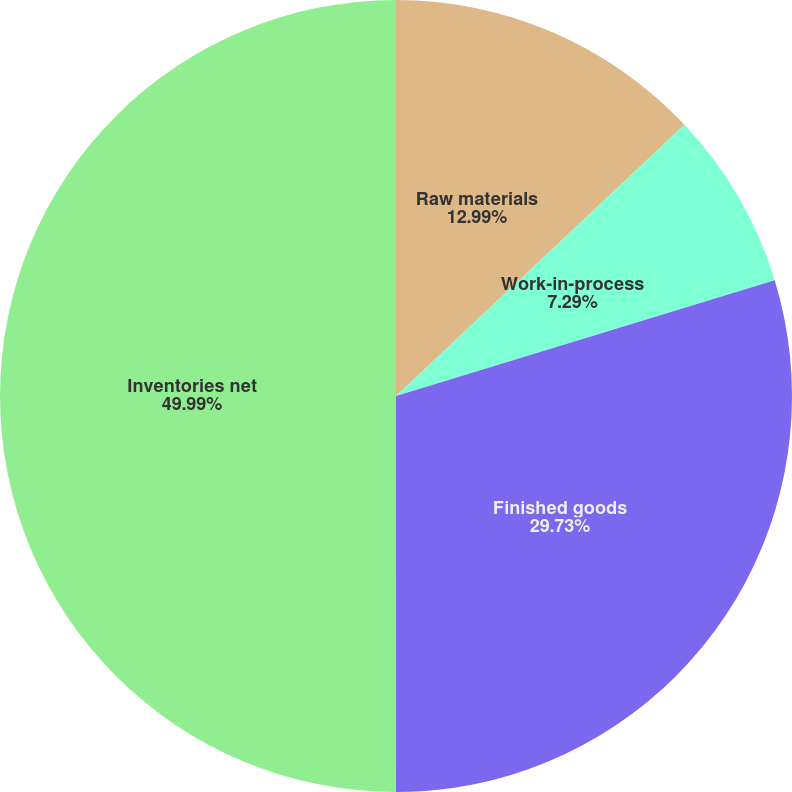Convert chart to OTSL. <chart><loc_0><loc_0><loc_500><loc_500><pie_chart><fcel>Raw materials<fcel>Work-in-process<fcel>Finished goods<fcel>Inventories net<nl><fcel>12.99%<fcel>7.29%<fcel>29.73%<fcel>50.0%<nl></chart> 